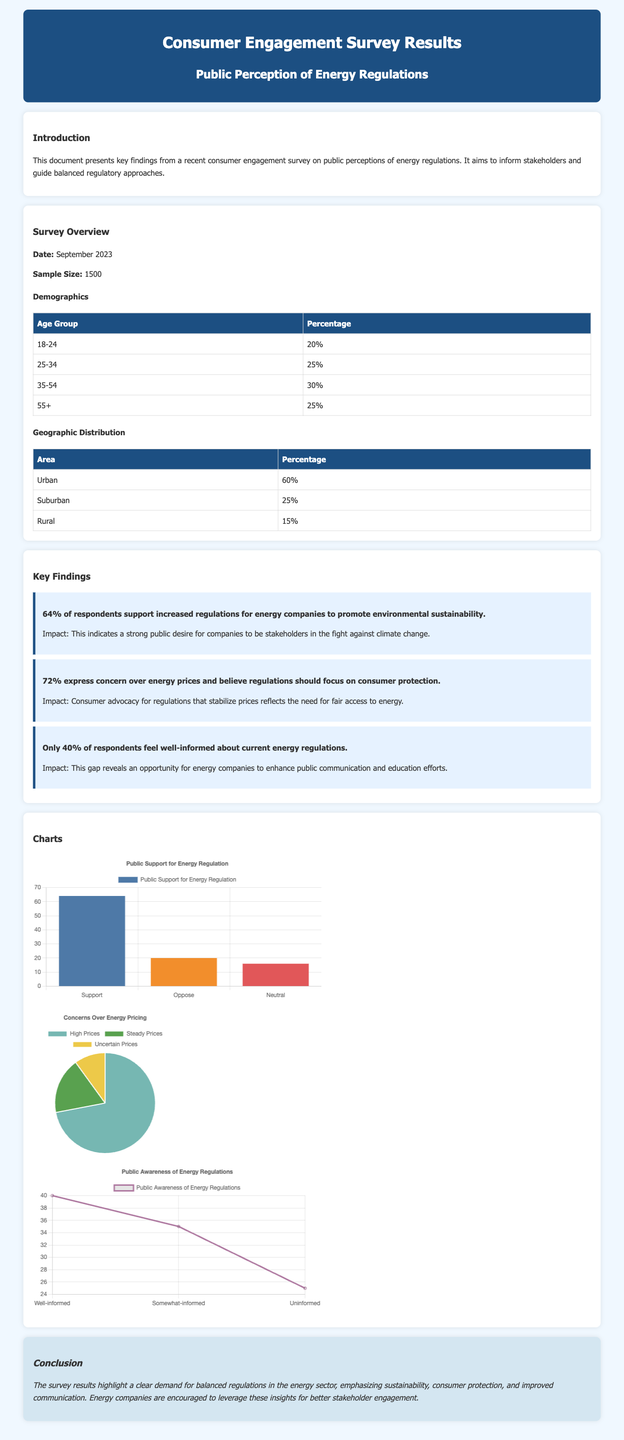What is the sample size of the survey? The sample size is mentioned in the document under the survey overview section.
Answer: 1500 What percentage of respondents support increased regulations for energy companies? This information is provided in the key findings section of the document.
Answer: 64% What is the age group with the highest percentage in the demographics? The demographics table lists various age groups and their percentages, allowing for this comparison.
Answer: 35-54 What percentage of respondents are located in urban areas? The demographic information on geographic distribution provides this detail.
Answer: 60% What do 72% of respondents express concern over? This finding relates to the public's priorities regarding energy regulations as stated in the key findings section.
Answer: Energy prices Which chart depicts public awareness of energy regulations? The title accompanying the chart will indicate the subject matter being illustrated.
Answer: Awareness Chart What is the percentage of respondents who feel well-informed about current energy regulations? This detail is found in the key findings, pointing out a gap in public knowledge.
Answer: 40% What demographic category comprises 25% of the respondents? This can be obtained from the demographics table, specifying age groups.
Answer: 25-34 What is the primary emphasis of the survey results in the conclusion? The conclusion summarizes the main themes derived from the survey data.
Answer: Balanced regulations 